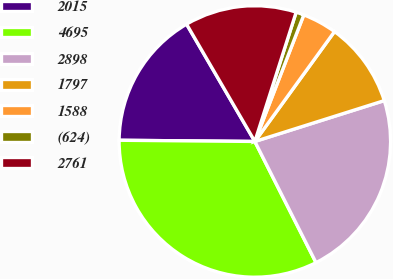<chart> <loc_0><loc_0><loc_500><loc_500><pie_chart><fcel>2015<fcel>4695<fcel>2898<fcel>1797<fcel>1588<fcel>(624)<fcel>2761<nl><fcel>16.47%<fcel>32.58%<fcel>22.43%<fcel>10.15%<fcel>4.11%<fcel>0.95%<fcel>13.31%<nl></chart> 